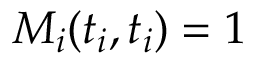Convert formula to latex. <formula><loc_0><loc_0><loc_500><loc_500>M _ { i } ( t _ { i } , t _ { i } ) = 1</formula> 